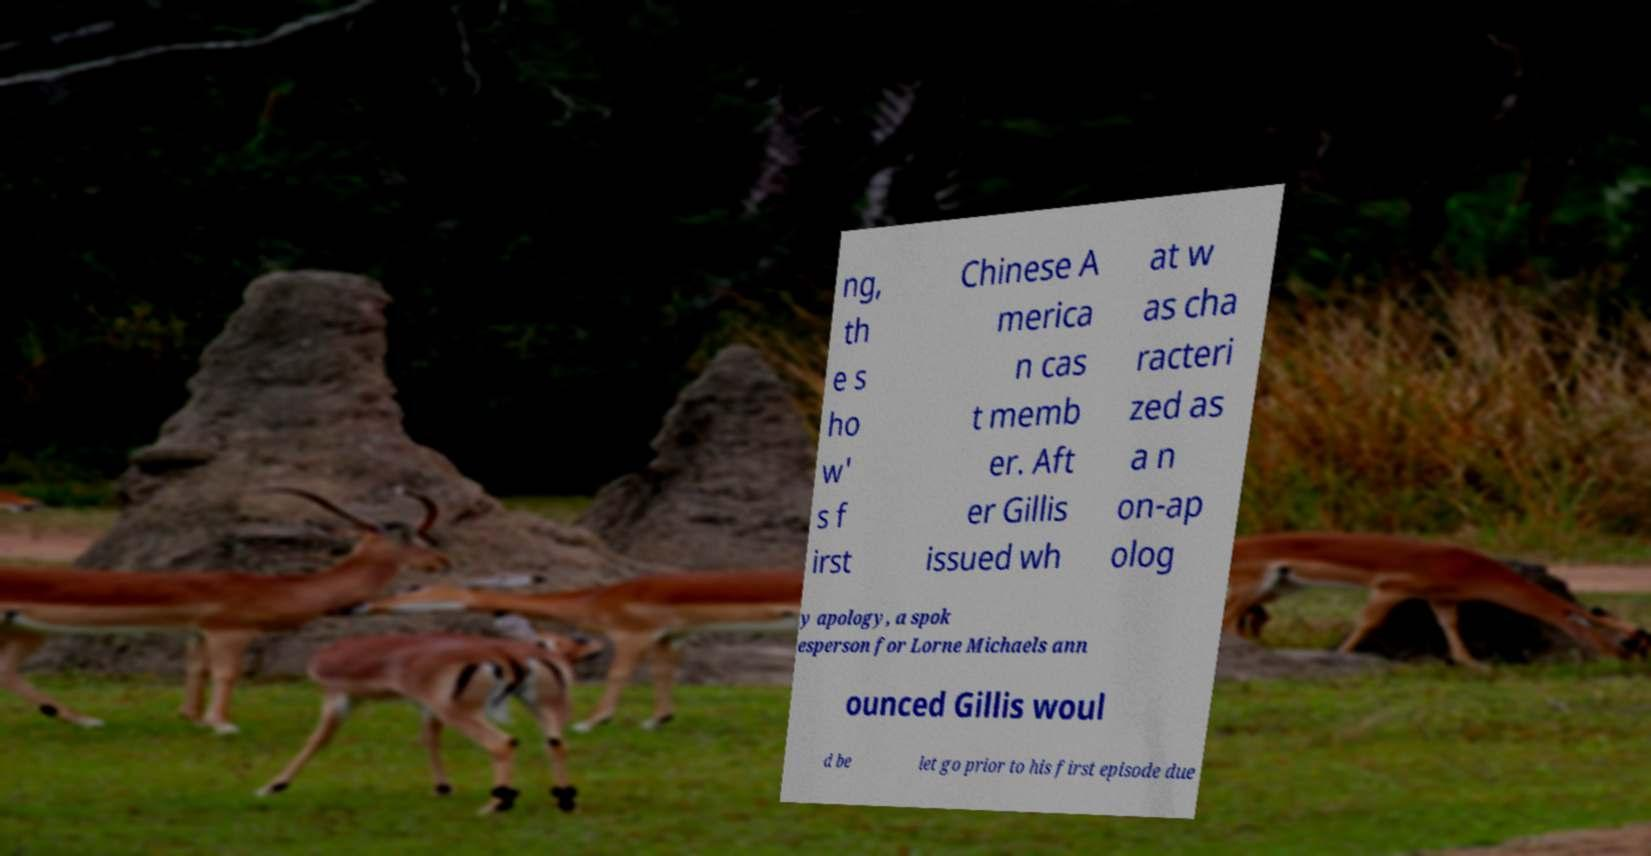Could you extract and type out the text from this image? ng, th e s ho w' s f irst Chinese A merica n cas t memb er. Aft er Gillis issued wh at w as cha racteri zed as a n on-ap olog y apology, a spok esperson for Lorne Michaels ann ounced Gillis woul d be let go prior to his first episode due 